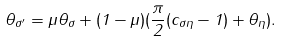<formula> <loc_0><loc_0><loc_500><loc_500>\theta _ { \sigma ^ { \prime } } = \mu \theta _ { \sigma } + ( 1 - \mu ) ( \frac { \pi } { 2 } ( c _ { \sigma \eta } - 1 ) + \theta _ { \eta } ) .</formula> 